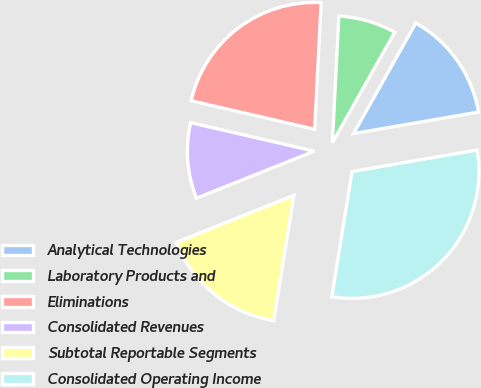Convert chart to OTSL. <chart><loc_0><loc_0><loc_500><loc_500><pie_chart><fcel>Analytical Technologies<fcel>Laboratory Products and<fcel>Eliminations<fcel>Consolidated Revenues<fcel>Subtotal Reportable Segments<fcel>Consolidated Operating Income<nl><fcel>14.12%<fcel>7.36%<fcel>22.19%<fcel>9.66%<fcel>16.4%<fcel>30.26%<nl></chart> 